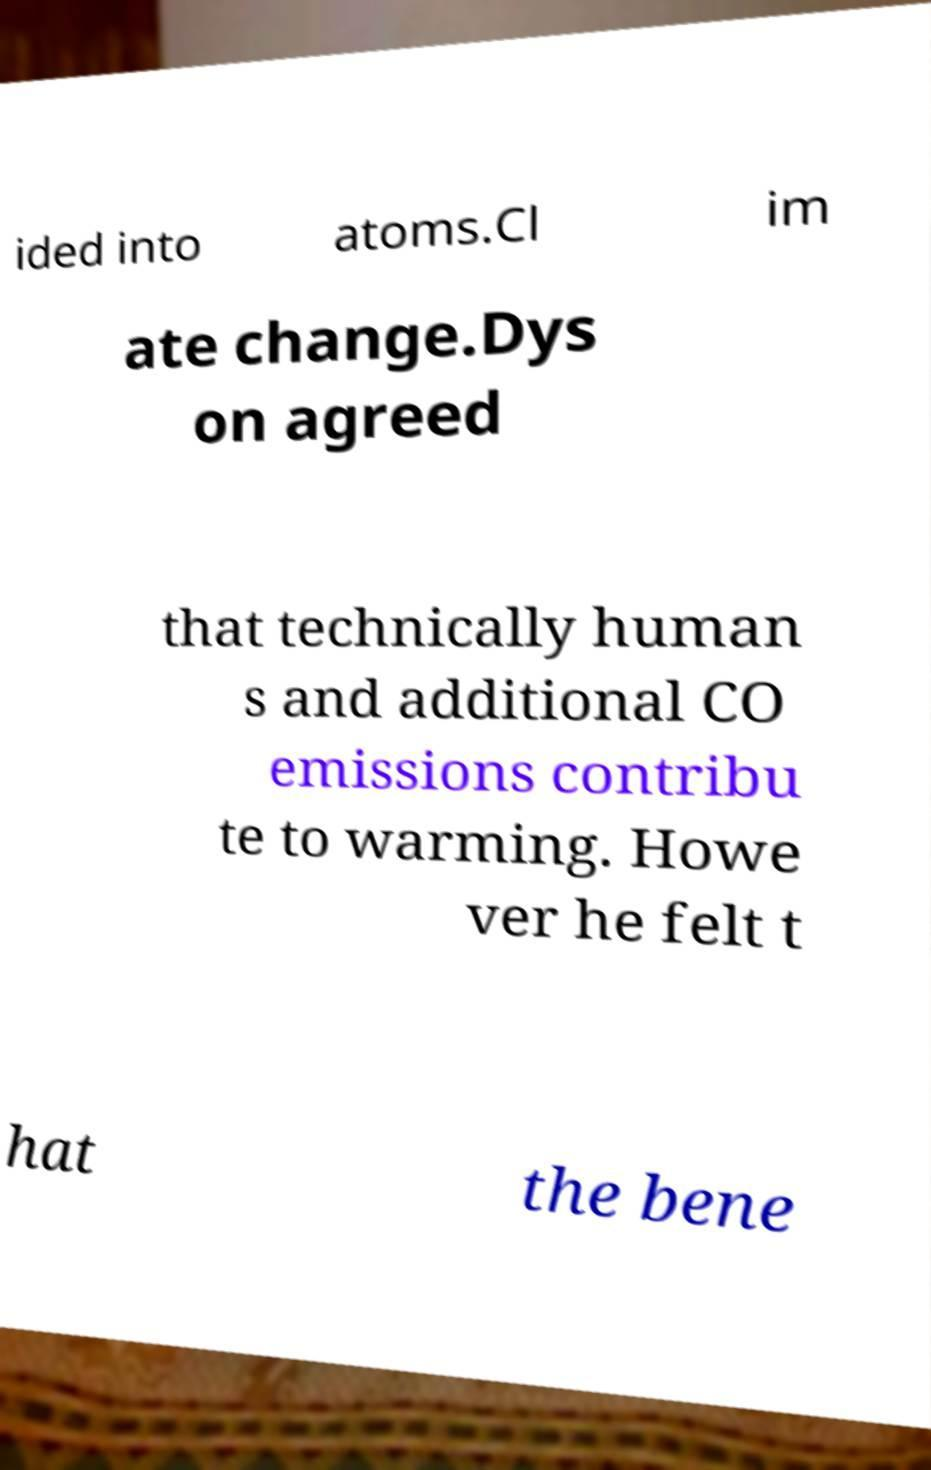There's text embedded in this image that I need extracted. Can you transcribe it verbatim? ided into atoms.Cl im ate change.Dys on agreed that technically human s and additional CO emissions contribu te to warming. Howe ver he felt t hat the bene 